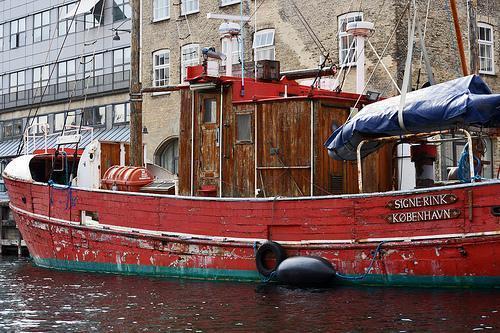How many boats are there?
Give a very brief answer. 1. 